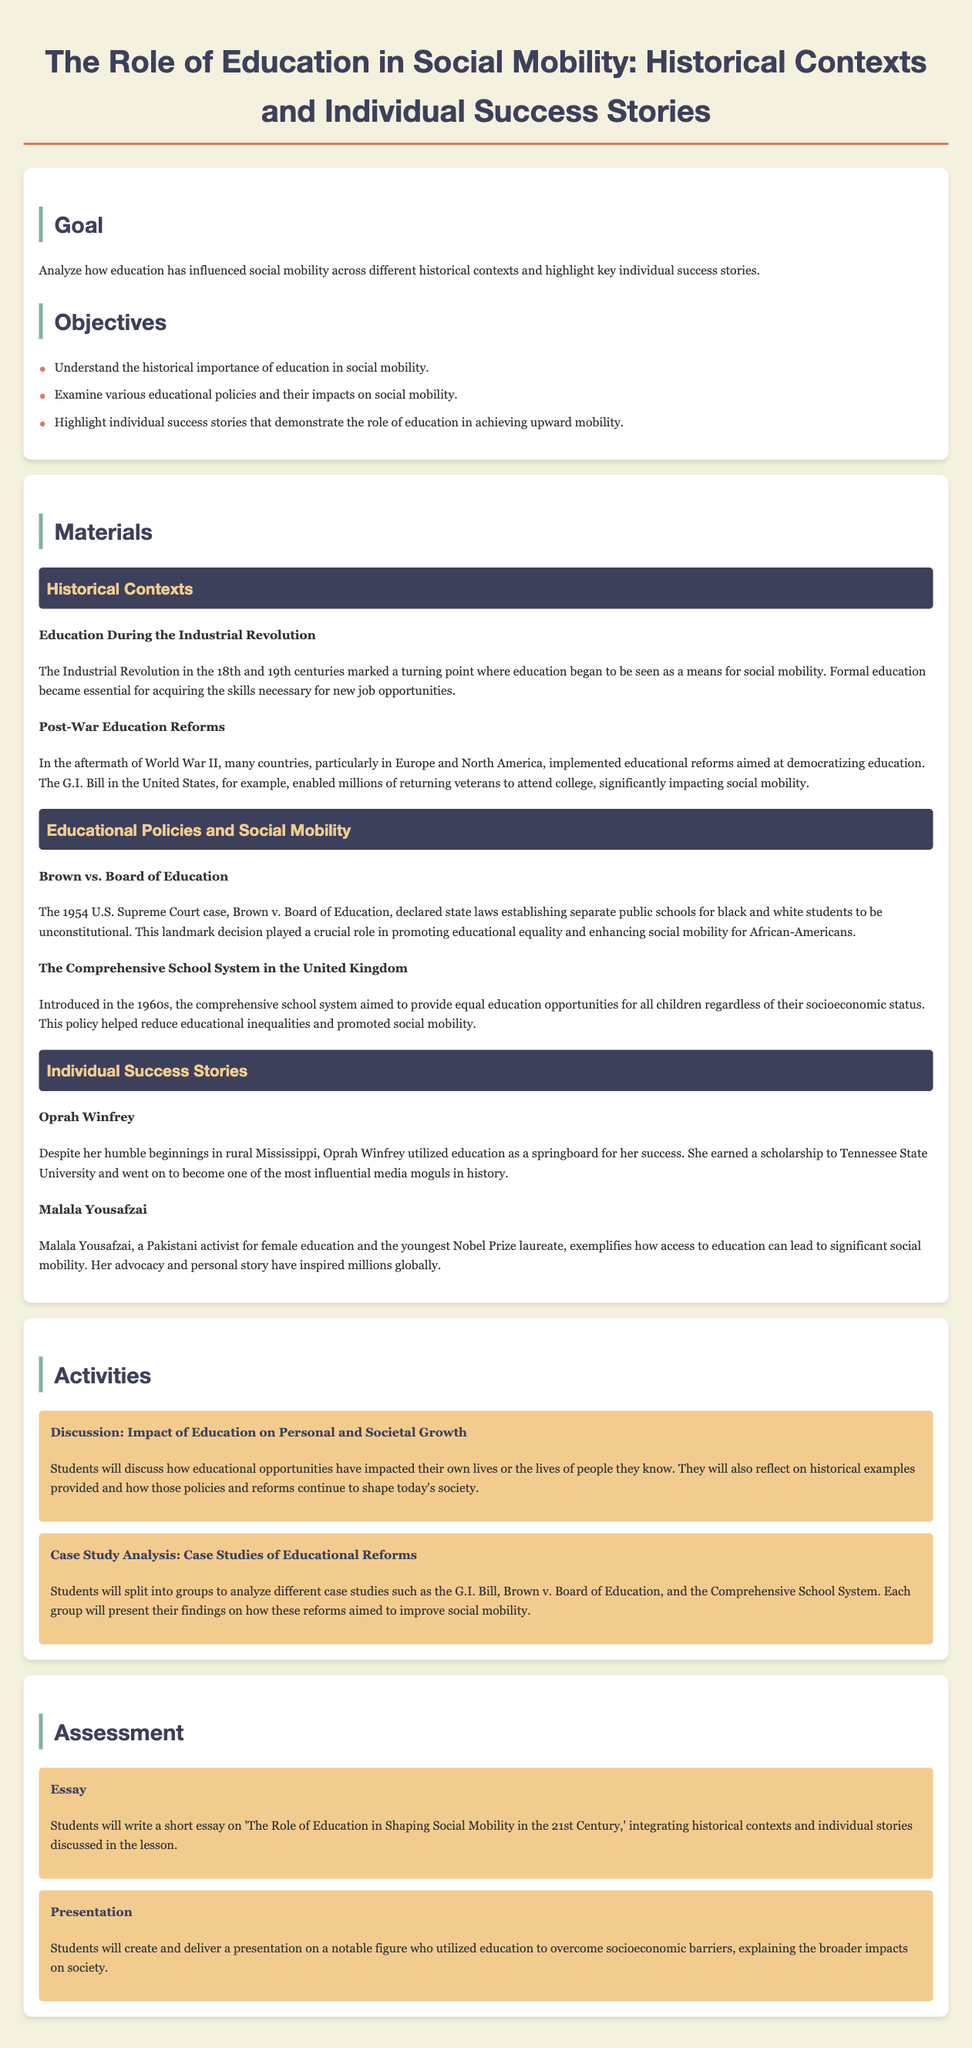What is the goal of the lesson plan? The goal of the lesson plan is to analyze how education has influenced social mobility across different historical contexts and highlight key individual success stories.
Answer: Analyze how education has influenced social mobility across different historical contexts and highlight key individual success stories Which Supreme Court case is mentioned in relation to educational equality? The document refers to the landmark case that declared state laws establishing separate public schools for black and white students unconstitutional.
Answer: Brown vs. Board of Education Who is a notable individual success story highlighted in the lesson plan? The lesson plan provides examples of individuals who utilized education for upward mobility, such as media mogul Oprah Winfrey.
Answer: Oprah Winfrey What type of assessment involves writing an essay? One of the assessments mentioned requires students to reflect on the role of education in social mobility through written work.
Answer: Essay What historical era is associated with the discussion of education in this lesson plan? The lesson plan discusses education's role in social mobility during significant historical periods, including the Industrial Revolution.
Answer: Industrial Revolution What impact did the G.I. Bill have on education? The document highlights the G.I. Bill as a significant educational reform that enabled many returning veterans to attend college, influencing social mobility.
Answer: Enabled millions of returning veterans to attend college What are students expected to do during the case study analysis activity? Students split into groups to analyze different educational reform case studies and present their findings on social mobility improvement.
Answer: Analyze different case studies and present findings What is one educational policy discussed that aimed to reduce inequalities? The lesson plan mentions a comprehensive school system implemented to address educational inequalities and promote social mobility in the UK.
Answer: The Comprehensive School System in the United Kingdom 